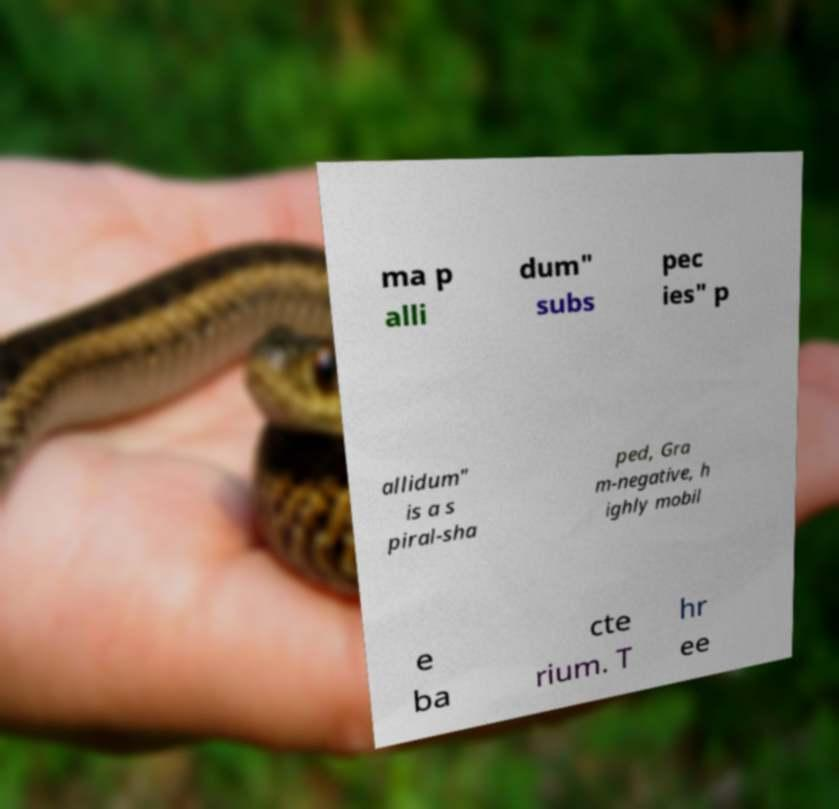Can you accurately transcribe the text from the provided image for me? ma p alli dum" subs pec ies" p allidum" is a s piral-sha ped, Gra m-negative, h ighly mobil e ba cte rium. T hr ee 